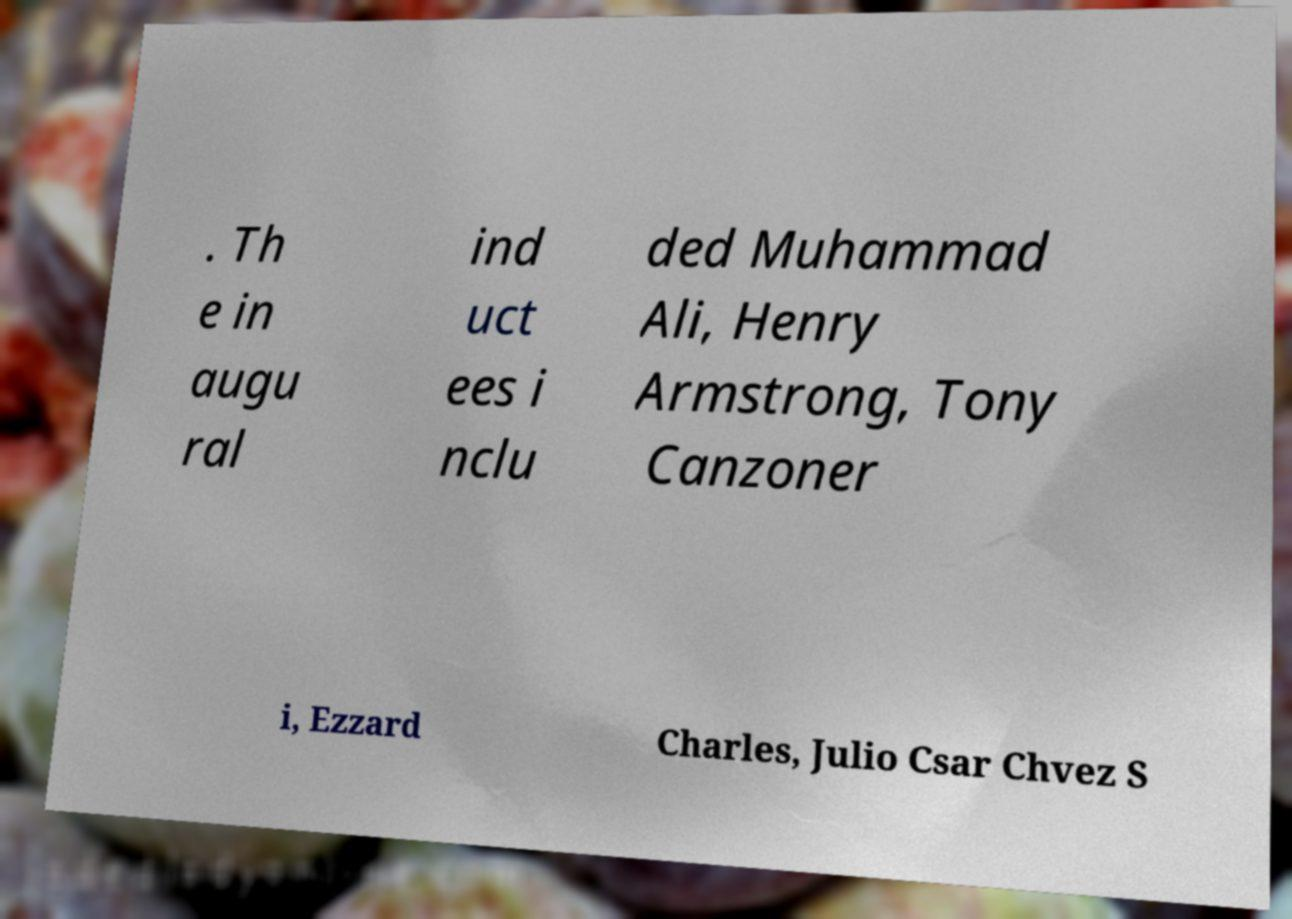Could you assist in decoding the text presented in this image and type it out clearly? . Th e in augu ral ind uct ees i nclu ded Muhammad Ali, Henry Armstrong, Tony Canzoner i, Ezzard Charles, Julio Csar Chvez S 